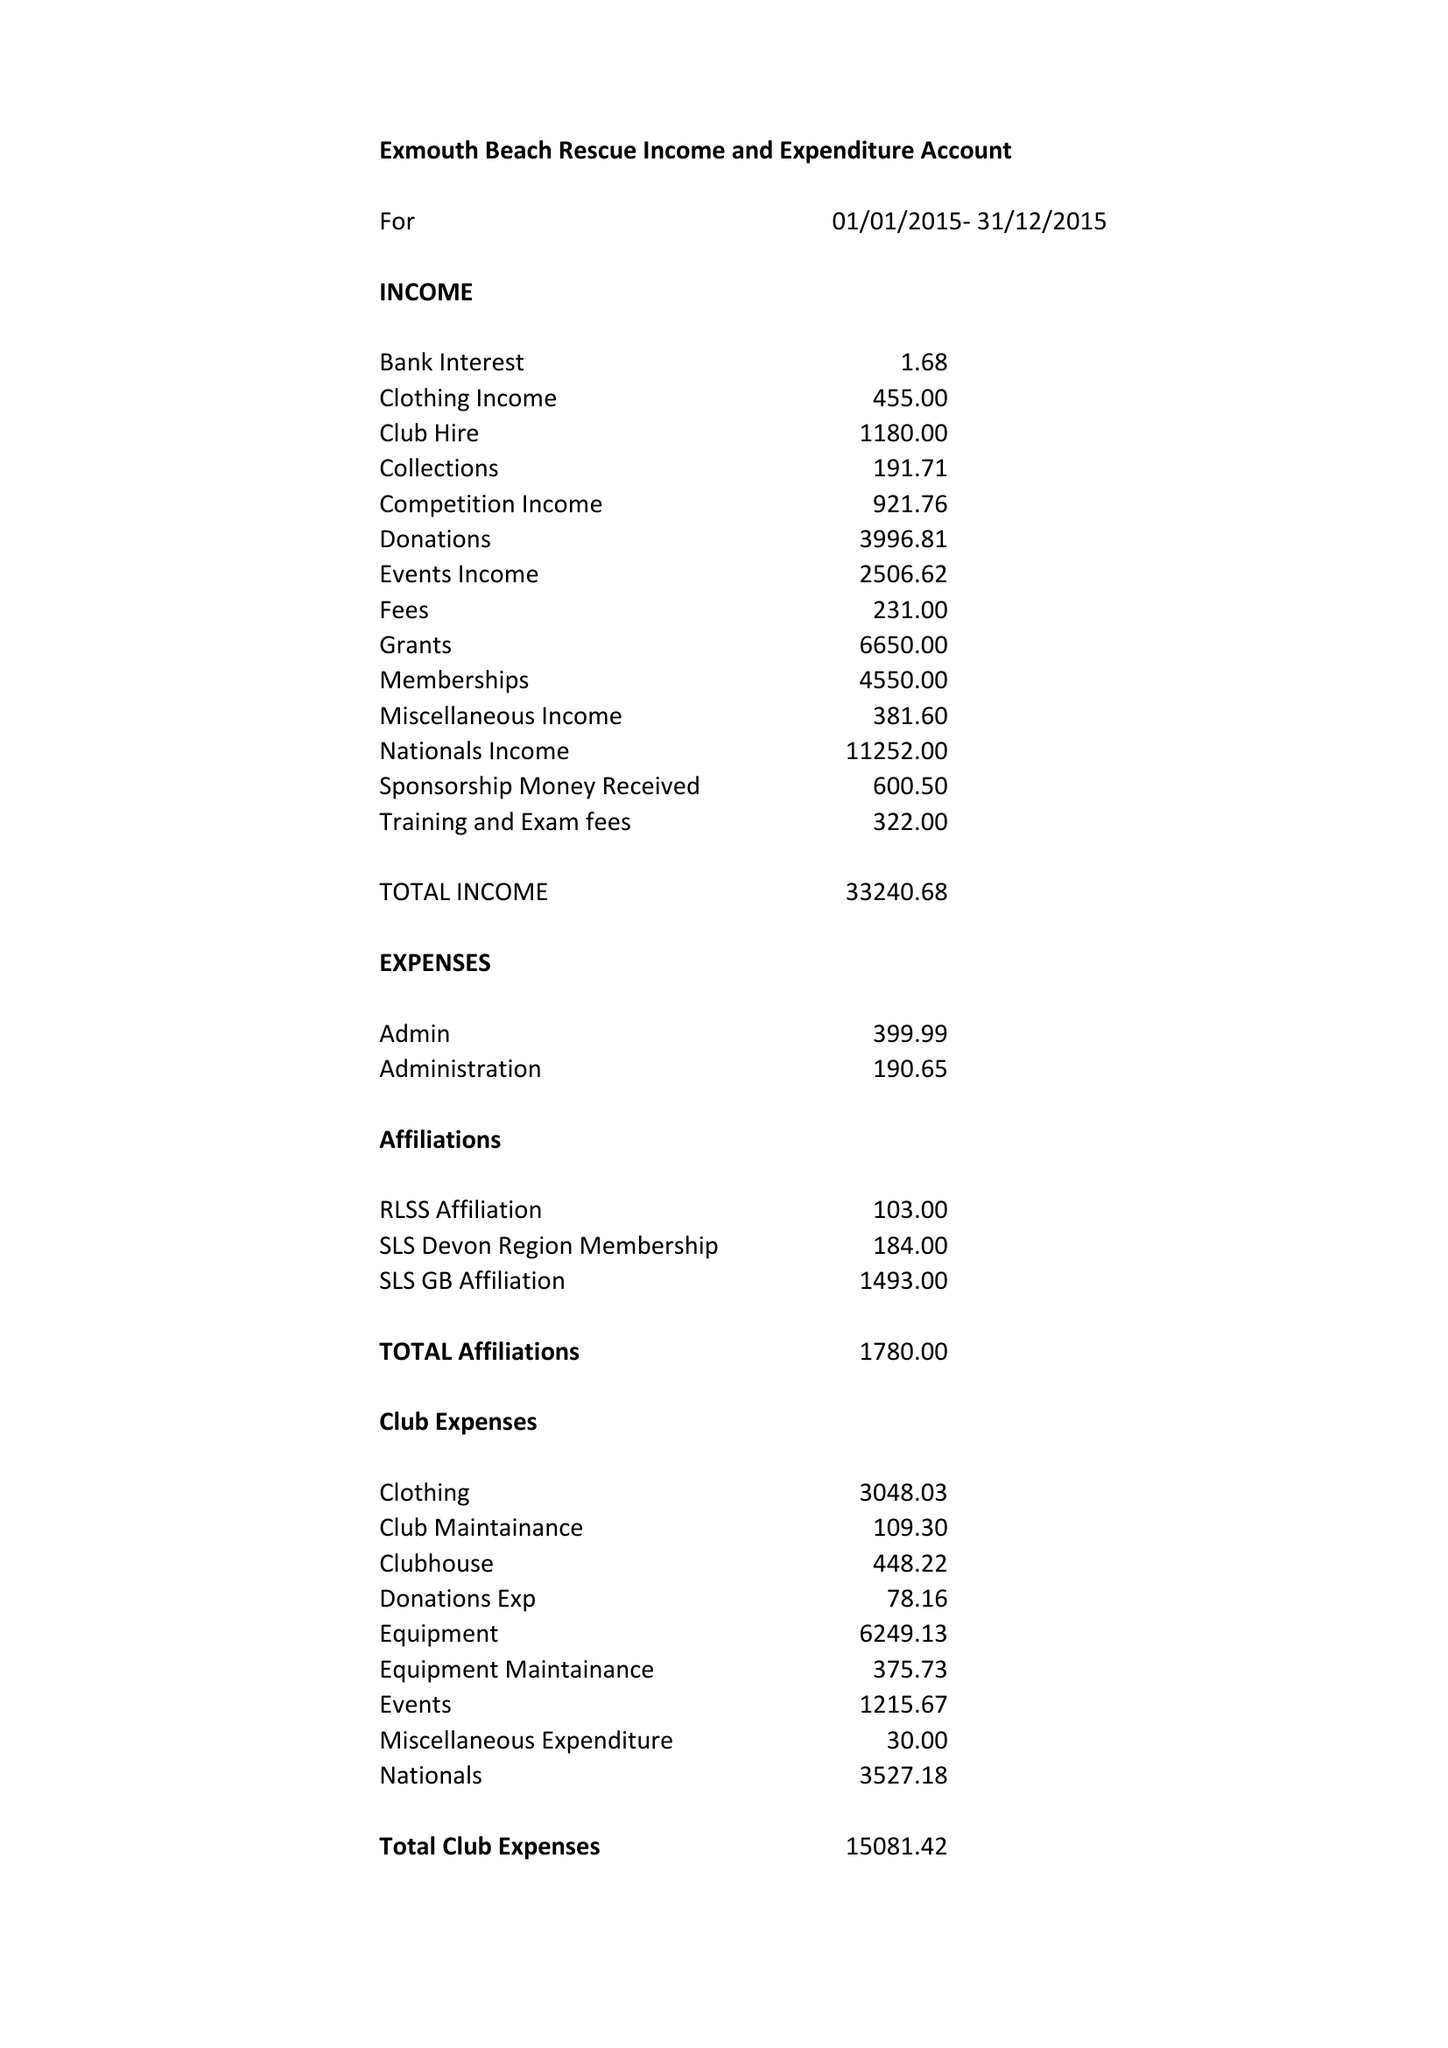What is the value for the charity_number?
Answer the question using a single word or phrase. 1025654 